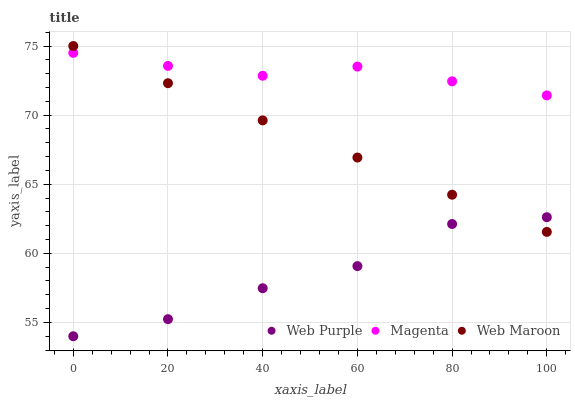Does Web Purple have the minimum area under the curve?
Answer yes or no. Yes. Does Magenta have the maximum area under the curve?
Answer yes or no. Yes. Does Web Maroon have the minimum area under the curve?
Answer yes or no. No. Does Web Maroon have the maximum area under the curve?
Answer yes or no. No. Is Web Maroon the smoothest?
Answer yes or no. Yes. Is Web Purple the roughest?
Answer yes or no. Yes. Is Magenta the smoothest?
Answer yes or no. No. Is Magenta the roughest?
Answer yes or no. No. Does Web Purple have the lowest value?
Answer yes or no. Yes. Does Web Maroon have the lowest value?
Answer yes or no. No. Does Web Maroon have the highest value?
Answer yes or no. Yes. Does Magenta have the highest value?
Answer yes or no. No. Is Web Purple less than Magenta?
Answer yes or no. Yes. Is Magenta greater than Web Purple?
Answer yes or no. Yes. Does Magenta intersect Web Maroon?
Answer yes or no. Yes. Is Magenta less than Web Maroon?
Answer yes or no. No. Is Magenta greater than Web Maroon?
Answer yes or no. No. Does Web Purple intersect Magenta?
Answer yes or no. No. 